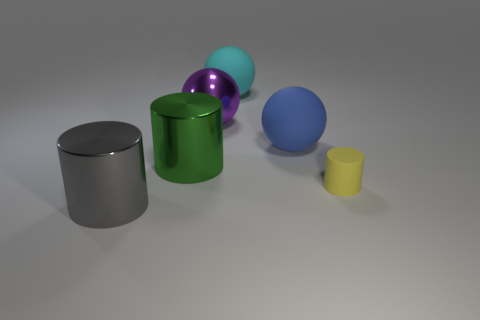How many objects are either large metallic objects that are behind the tiny thing or cyan spheres?
Make the answer very short. 3. Are there fewer big purple spheres that are in front of the tiny cylinder than matte spheres in front of the big blue sphere?
Ensure brevity in your answer.  No. There is a big cyan sphere; are there any blue spheres on the left side of it?
Your response must be concise. No. How many objects are objects to the left of the yellow rubber thing or big shiny cylinders that are behind the large gray object?
Your answer should be compact. 5. How many large cylinders are the same color as the tiny rubber cylinder?
Ensure brevity in your answer.  0. There is another metal object that is the same shape as the green object; what is its color?
Give a very brief answer. Gray. There is a big object that is to the right of the purple sphere and in front of the cyan object; what shape is it?
Your answer should be compact. Sphere. Is the number of large brown objects greater than the number of large gray metallic objects?
Offer a very short reply. No. What is the material of the large green cylinder?
Give a very brief answer. Metal. Is there any other thing that has the same size as the green cylinder?
Offer a terse response. Yes. 